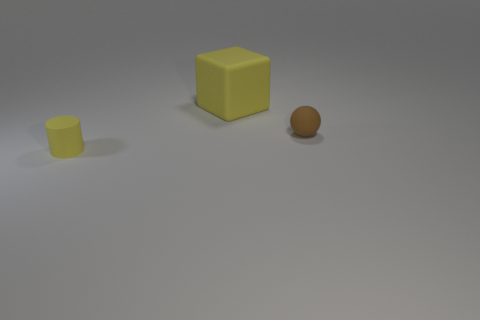Is there any other thing that is the same size as the yellow block?
Make the answer very short. No. Are there any other things that are the same shape as the tiny yellow matte thing?
Offer a very short reply. No. Are there any cylinders of the same color as the small rubber ball?
Make the answer very short. No. The rubber cube is what color?
Provide a short and direct response. Yellow. What is the size of the rubber thing in front of the matte object that is on the right side of the yellow matte thing that is behind the yellow matte cylinder?
Offer a terse response. Small. How many other objects are there of the same size as the yellow rubber cylinder?
Your answer should be compact. 1. What number of yellow cylinders are made of the same material as the brown sphere?
Your answer should be compact. 1. What is the shape of the small object right of the yellow cylinder?
Provide a short and direct response. Sphere. Is the material of the tiny cylinder the same as the tiny thing to the right of the big object?
Keep it short and to the point. Yes. Are any balls visible?
Your answer should be very brief. Yes. 